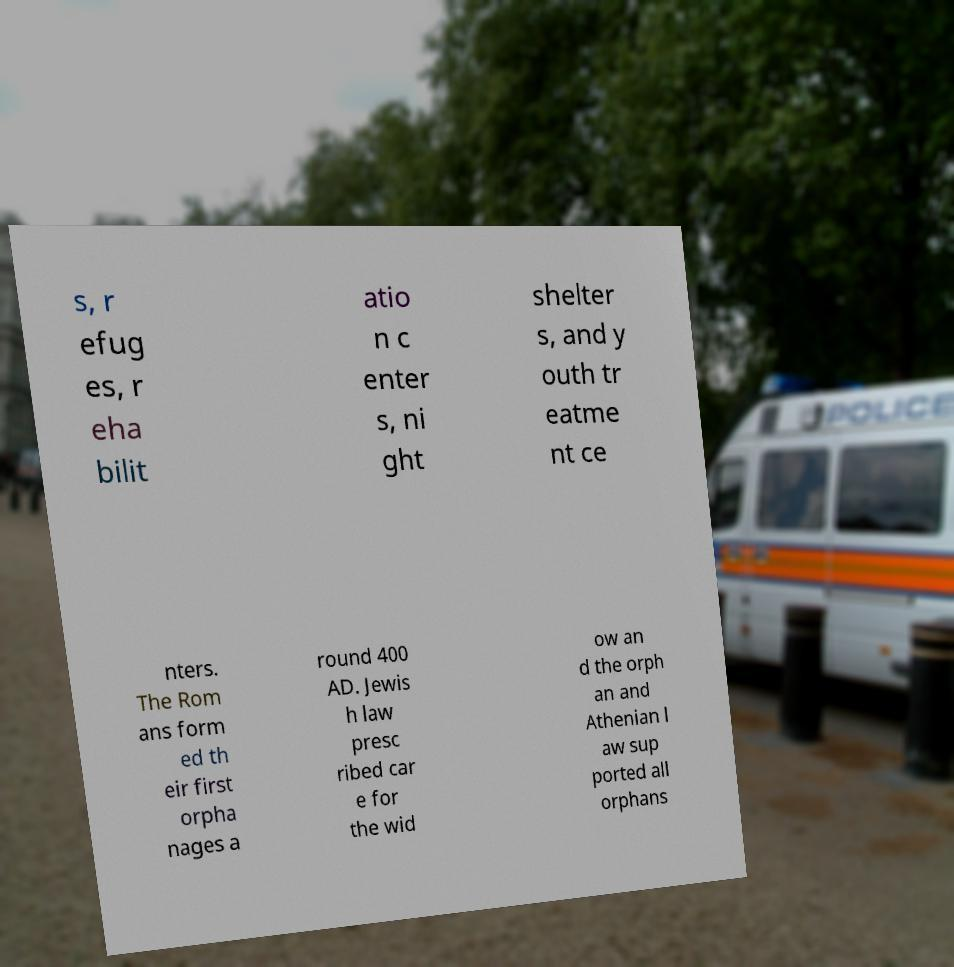I need the written content from this picture converted into text. Can you do that? s, r efug es, r eha bilit atio n c enter s, ni ght shelter s, and y outh tr eatme nt ce nters. The Rom ans form ed th eir first orpha nages a round 400 AD. Jewis h law presc ribed car e for the wid ow an d the orph an and Athenian l aw sup ported all orphans 